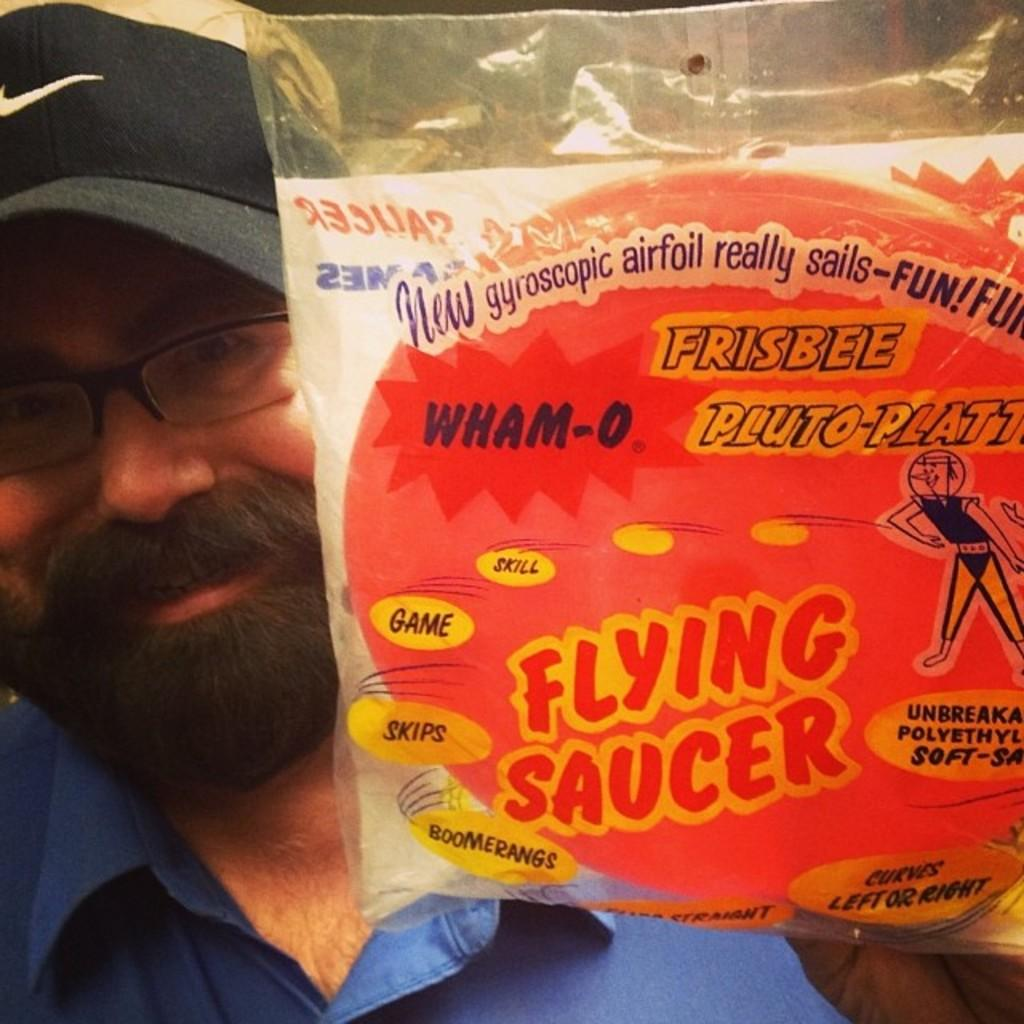What is the main subject of the image? There is a person in the image. What is the person holding in the image? The person is holding a packet. What type of effect does the goldfish have on the person in the image? There is no goldfish present in the image, so it is not possible to determine any effect it might have on the person. 